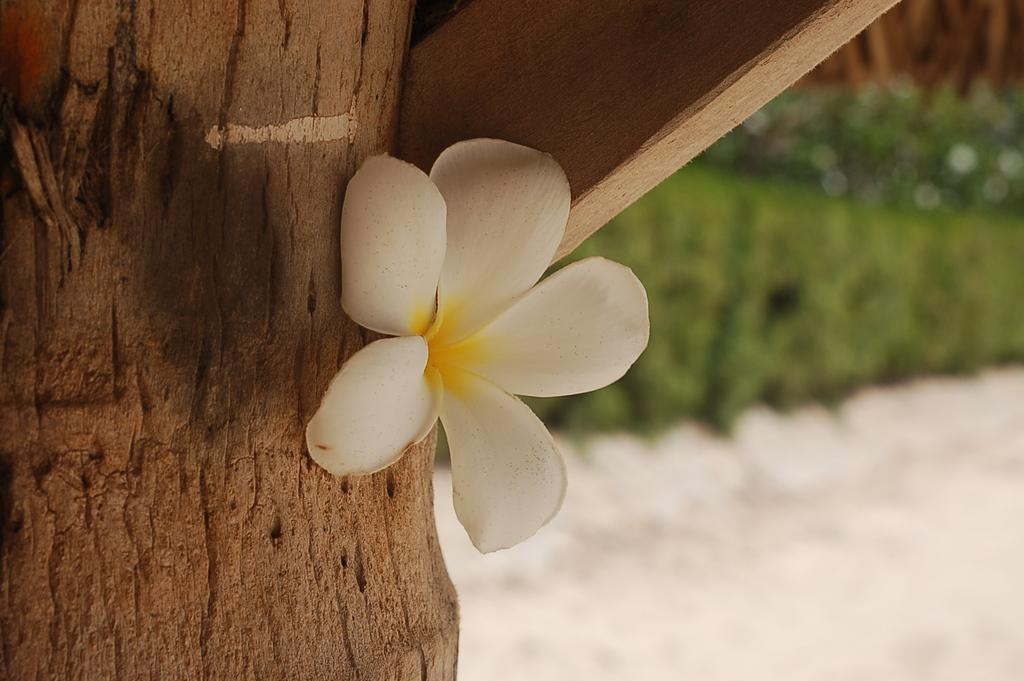What type of flower is in the image? There is a white flower in the image. What material is the wooden log made of? The wooden log is made of wood. What can be seen in the image besides the white flower and wooden log? There is a plank in the image. What type of silk shirt is the mom wearing in the image? There is no mom or silk shirt present in the image. 